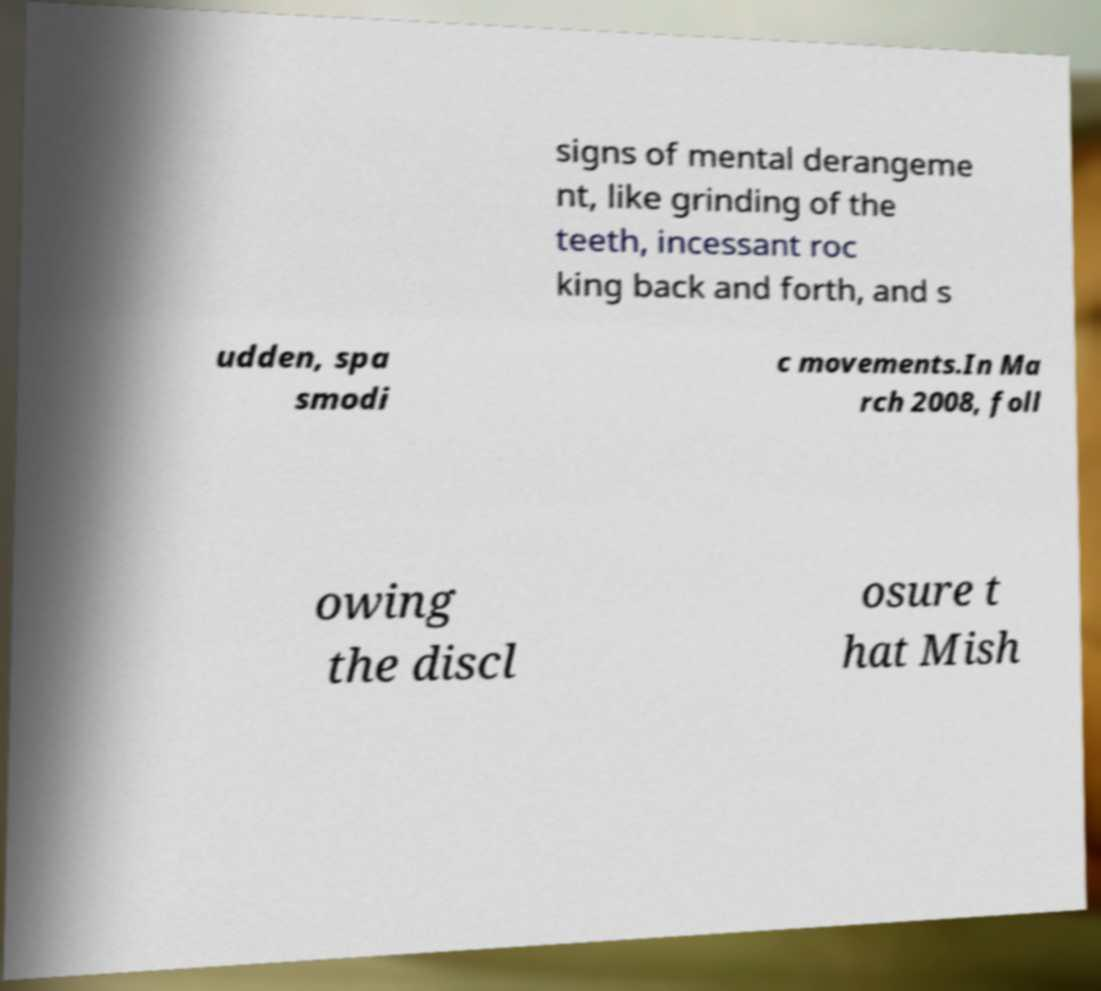Could you assist in decoding the text presented in this image and type it out clearly? signs of mental derangeme nt, like grinding of the teeth, incessant roc king back and forth, and s udden, spa smodi c movements.In Ma rch 2008, foll owing the discl osure t hat Mish 